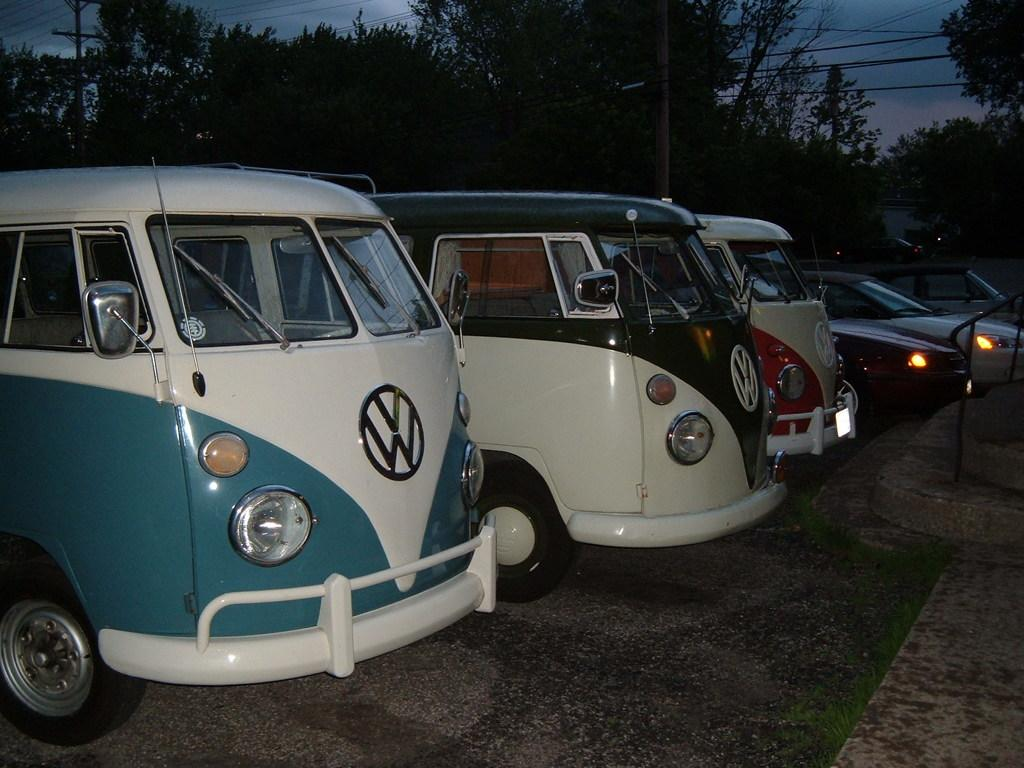What is happening in the image? There are vehicles on a road in the image. What can be seen in the background of the image? There are trees, poles, and wires in the background of the image. How many ladybugs are crawling on the plate in the image? There is no plate or ladybugs present in the image. 